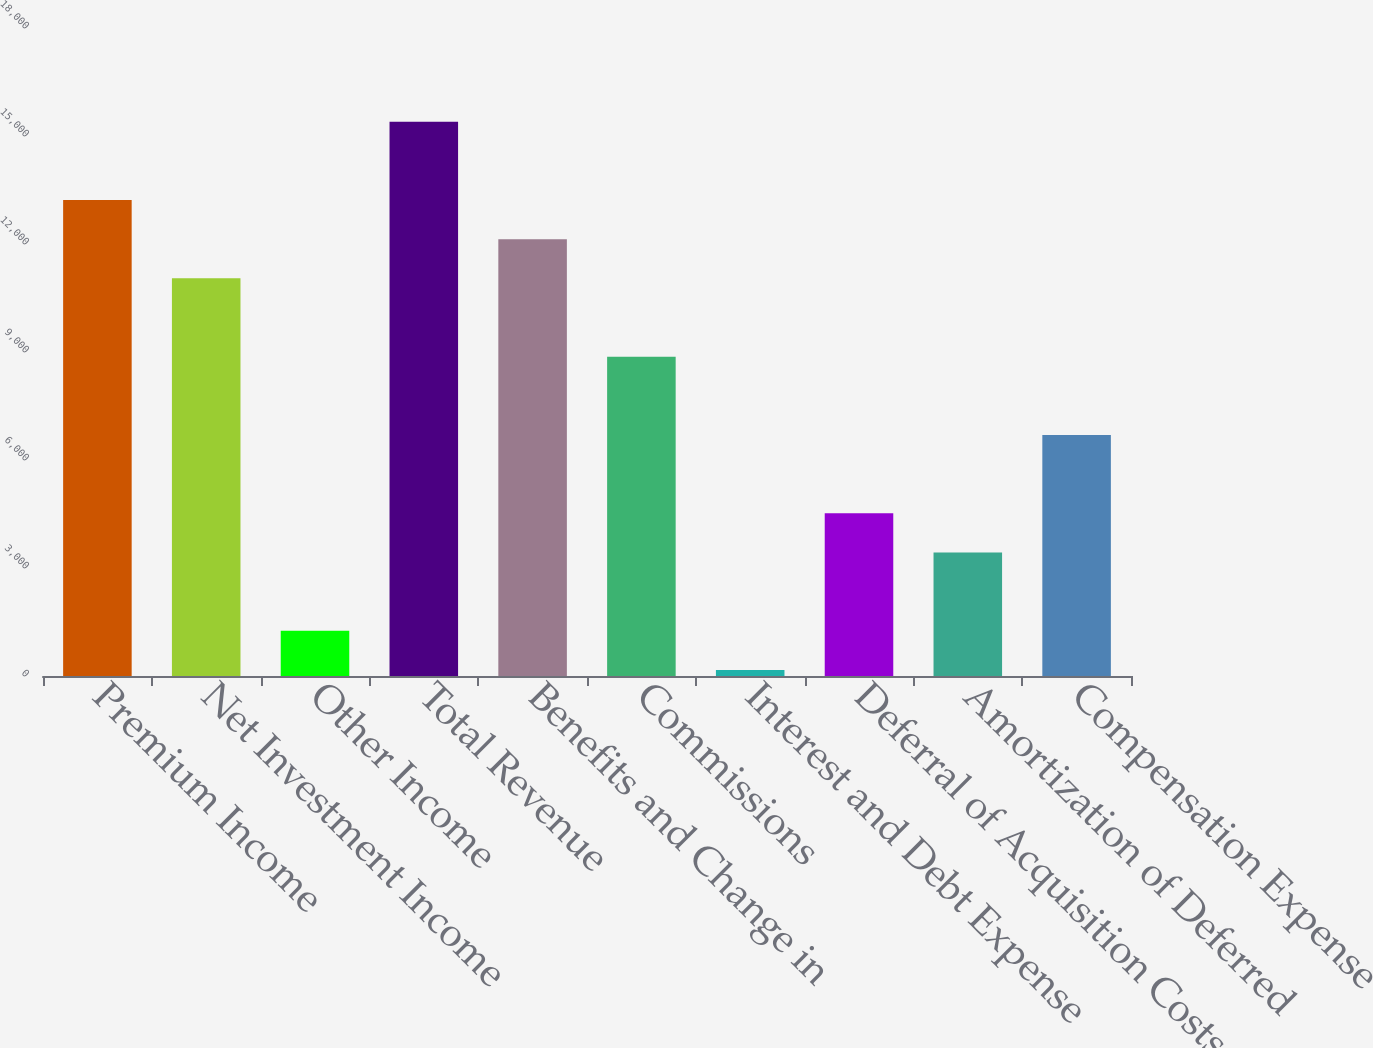Convert chart. <chart><loc_0><loc_0><loc_500><loc_500><bar_chart><fcel>Premium Income<fcel>Net Investment Income<fcel>Other Income<fcel>Total Revenue<fcel>Benefits and Change in<fcel>Commissions<fcel>Interest and Debt Expense<fcel>Deferral of Acquisition Costs<fcel>Amortization of Deferred<fcel>Compensation Expense<nl><fcel>13222.6<fcel>11046.5<fcel>1254.05<fcel>15398.7<fcel>12134.5<fcel>8870.4<fcel>166<fcel>4518.2<fcel>3430.15<fcel>6694.3<nl></chart> 